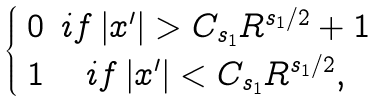<formula> <loc_0><loc_0><loc_500><loc_500>\begin{cases} \begin{array} { c c } 0 & i f \left | x ^ { \prime } \right | > C _ { s _ { 1 } } R ^ { s _ { 1 } / 2 } + 1 \\ 1 & i f \left | x ^ { \prime } \right | < C _ { s _ { 1 } } R ^ { s _ { 1 } / 2 } , \end{array} \end{cases}</formula> 